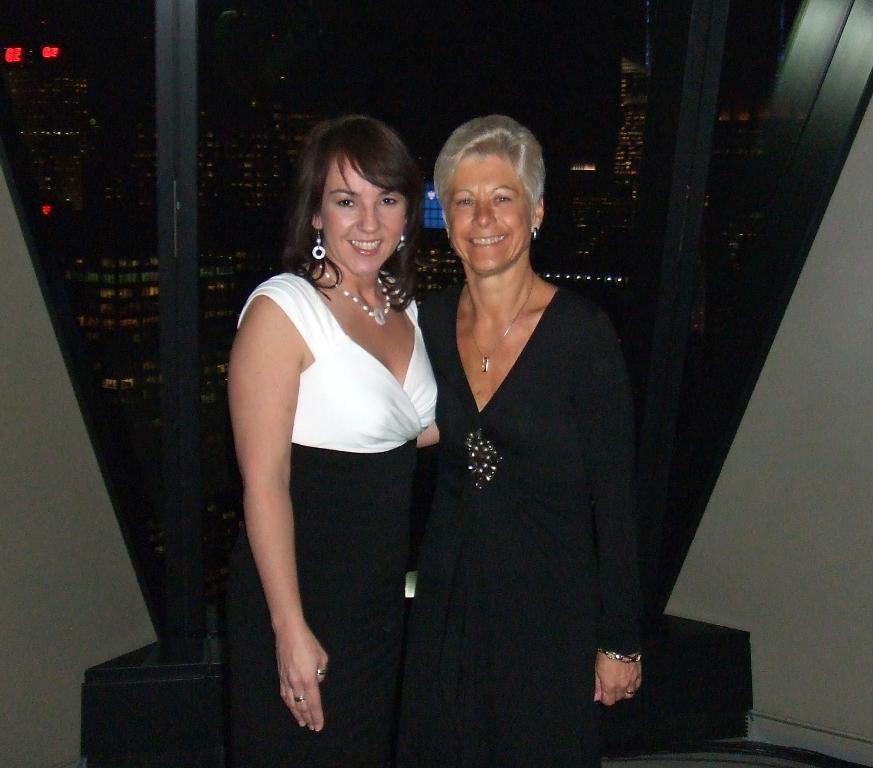In one or two sentences, can you explain what this image depicts? In this picture we can see two women standing and smiling. There are glass objects. Through these glass objects, we can see buildings and lights. 